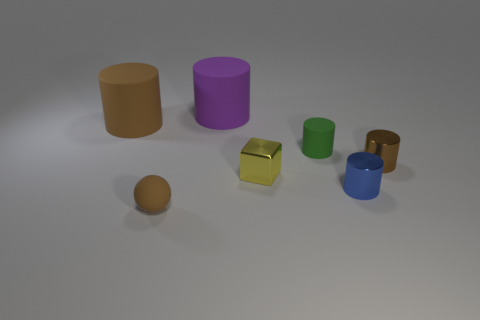There is a green thing that is the same shape as the purple thing; what material is it?
Your answer should be compact. Rubber. What number of objects are brown objects left of the big purple thing or matte cylinders that are left of the tiny green rubber thing?
Give a very brief answer. 3. Is the color of the cube the same as the rubber object that is in front of the small yellow metal cube?
Make the answer very short. No. There is a tiny brown thing that is made of the same material as the large purple cylinder; what shape is it?
Make the answer very short. Sphere. How many yellow cubes are there?
Provide a short and direct response. 1. How many things are metal objects that are on the right side of the yellow metal object or big rubber things?
Make the answer very short. 4. Do the tiny cylinder that is behind the tiny brown metal object and the metallic cube have the same color?
Keep it short and to the point. No. How many other objects are there of the same color as the small shiny cube?
Provide a short and direct response. 0. What number of big things are either green cylinders or blue metallic cylinders?
Offer a very short reply. 0. Are there more red metallic spheres than tiny brown shiny cylinders?
Offer a terse response. No. 